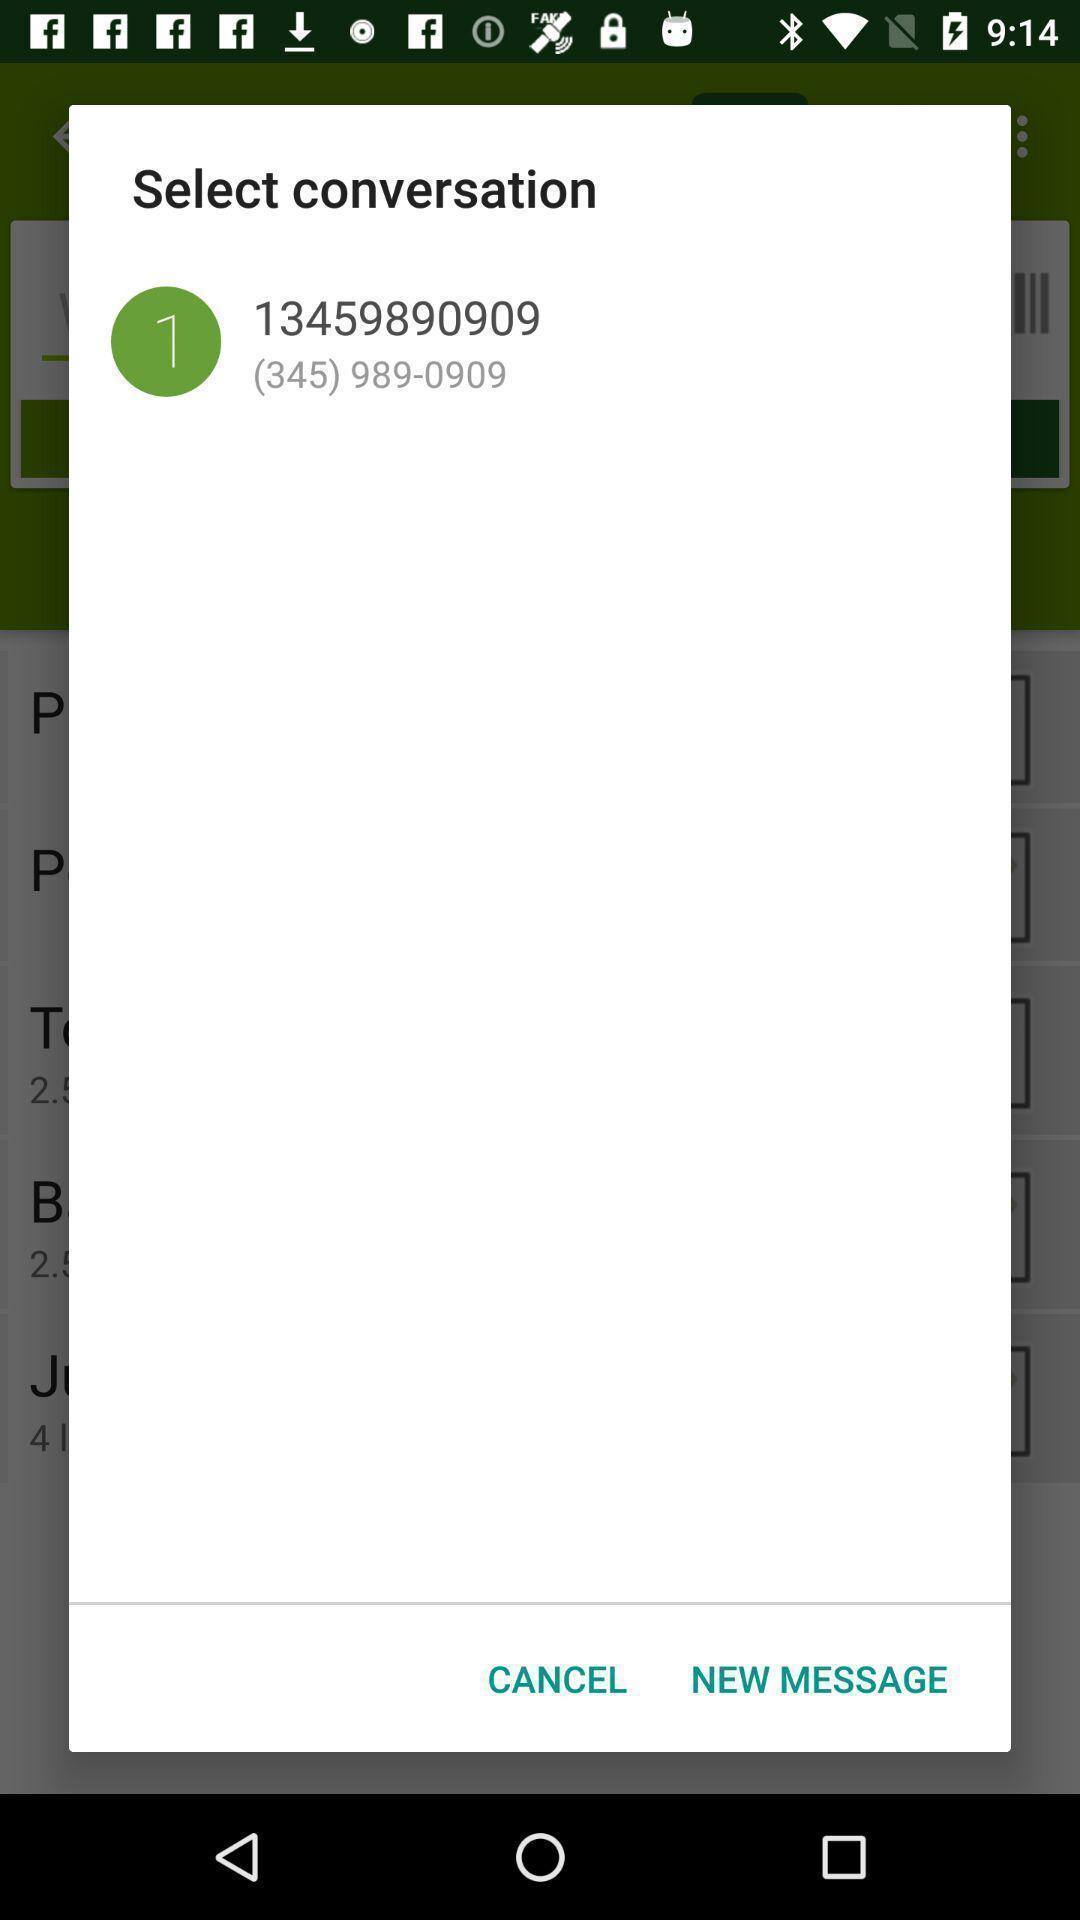Provide a description of this screenshot. Pop-up for selecting the conversation on messaging app. 